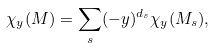Convert formula to latex. <formula><loc_0><loc_0><loc_500><loc_500>\chi _ { y } ( M ) = \sum _ { s } ( - y ) ^ { d _ { s } } \chi _ { y } ( M _ { s } ) ,</formula> 